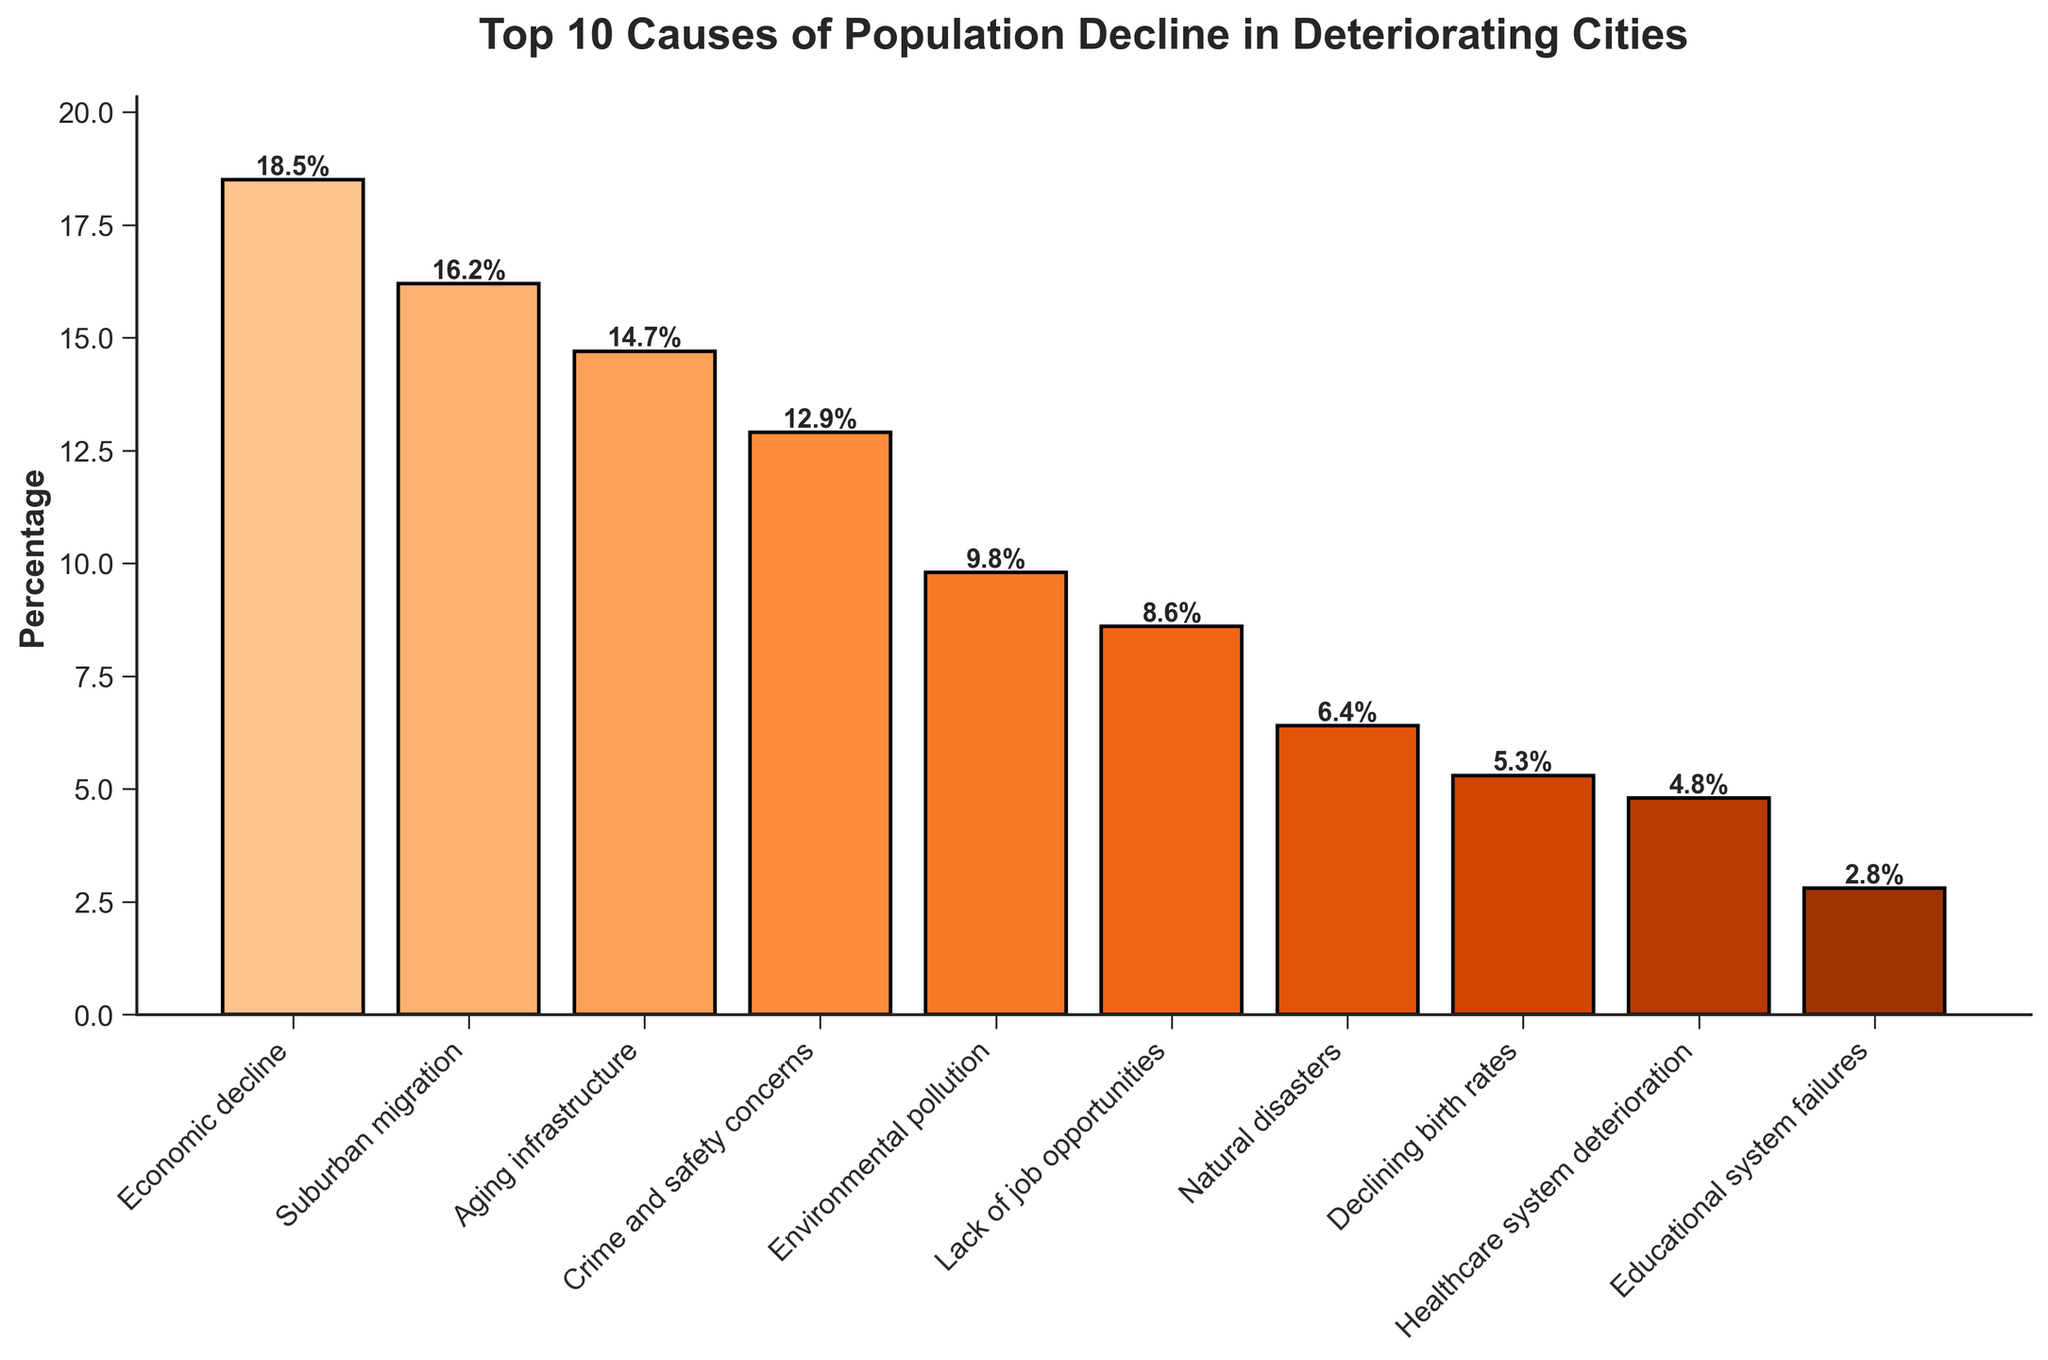what is the top cause of population decline in deteriorating cities? The bar chart shows percentages for various causes of population decline, ordered from highest to lowest. The highest percentage indicates the top cause. "Economic decline" has the highest percentage at 18.5%.
Answer: Economic decline What's the difference in percentage between economic decline and suburban migration? To find the difference, subtract the percentage of suburban migration (16.2%) from the percentage of economic decline (18.5%). The difference is 18.5% - 16.2% = 2.3%.
Answer: 2.3% What's the total percentage of population decline causes related to infrastructure (aging infrastructure) and pollution (environmental pollution)? To find the total, add the percentage of "Aging infrastructure" (14.7%) and "Environmental pollution" (9.8%). The sum is 14.7% + 9.8% = 24.5%.
Answer: 24.5% Which cause has a higher percentage: lack of job opportunities or healthcare system deterioration? Compare the percentages for "Lack of job opportunities" (8.6%) and "Healthcare system deterioration" (4.8%). "Lack of job opportunities" has a higher percentage.
Answer: Lack of job opportunities What is the percentage of population decline causes attributed to educational system failures, and how does it compare to the sum of crime and natural disasters? First, note that "Educational system failures" is 2.8%. Then, add "Crime and safety concerns" (12.9%) and "Natural disasters" (6.4%), which totals 12.9% + 6.4% = 19.3%. Compare 2.8% to 19.3%. Educational system failures are much lower.
Answer: 2.8%; much lower What’s the average percentage for the causes of population decline ranking in the top 5? Sum the top 5 percentages: 18.5% (Economic decline) + 16.2% (Suburban migration) + 14.7% (Aging infrastructure) + 12.9% (Crime and safety concerns) + 9.8% (Environmental pollution). The total sum is 72.1%. Divide by 5 to get the average: 72.1% / 5 = 14.42%.
Answer: 14.42% Between environmental pollution and declining birth rates, which has a higher percentage? Compare "Environmental pollution" (9.8%) to "Declining birth rates" (5.3%). "Environmental pollution" has a higher percentage.
Answer: Environmental pollution How much more significant is aging infrastructure compared to the healthcare system deterioration in terms of percentage? Subtract the percentage of "Healthcare system deterioration" (4.8%) from "Aging infrastructure" (14.7%). The difference is 14.7% - 4.8% = 9.9%.
Answer: 9.9% Which three causes of population decline have the lowest percentages, and what are their combined total? Identify the three lowest percentages: "Educational system failures" (2.8%), "Healthcare system deterioration" (4.8%), and "Declining birth rates" (5.3%). Add them up: 2.8% + 4.8% + 5.3% = 12.9%.
Answer: 12.9% What is the height in percentage of the bar that represents crime and safety concerns, and how does it visually compare to the bar for natural disasters? "Crime and safety concerns" is represented by a bar with a height of 12.9%, and "Natural disasters" have a height of 6.4%. Visually, the crime and safety concerns bar is about twice as high as the natural disasters bar.
Answer: 12.9%; about twice as high 